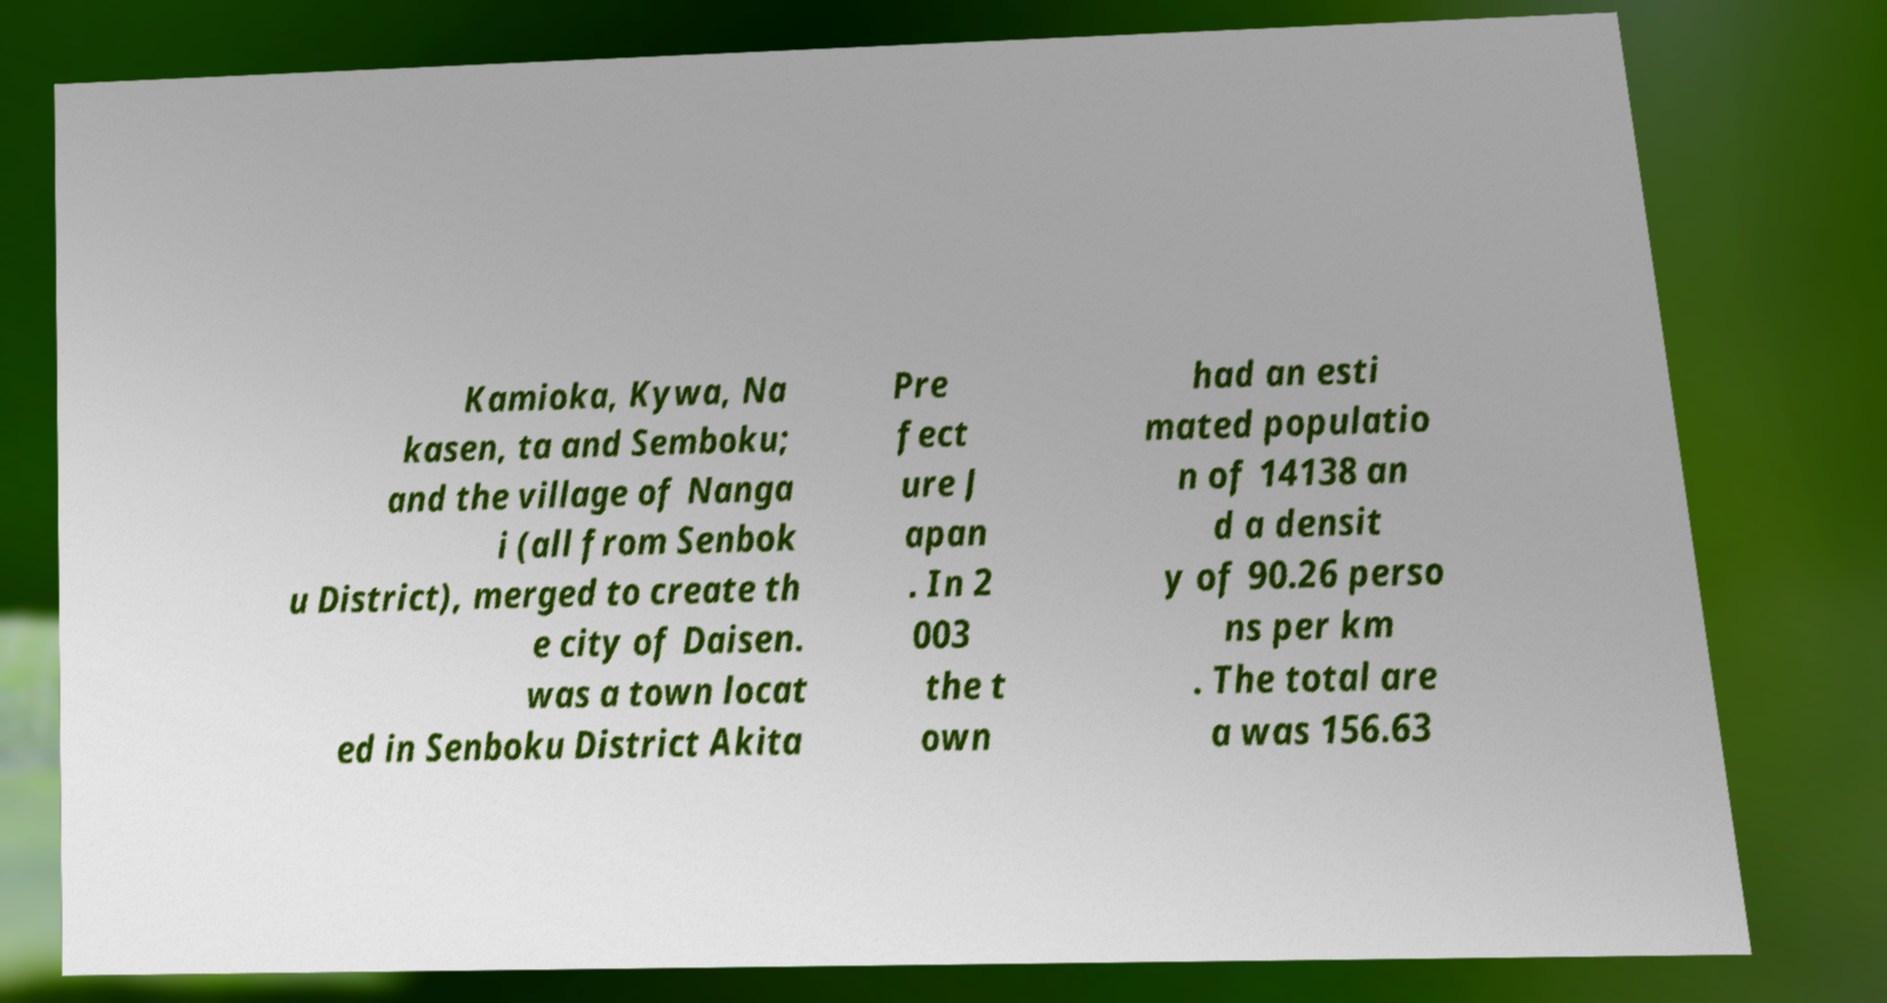What messages or text are displayed in this image? I need them in a readable, typed format. Kamioka, Kywa, Na kasen, ta and Semboku; and the village of Nanga i (all from Senbok u District), merged to create th e city of Daisen. was a town locat ed in Senboku District Akita Pre fect ure J apan . In 2 003 the t own had an esti mated populatio n of 14138 an d a densit y of 90.26 perso ns per km . The total are a was 156.63 